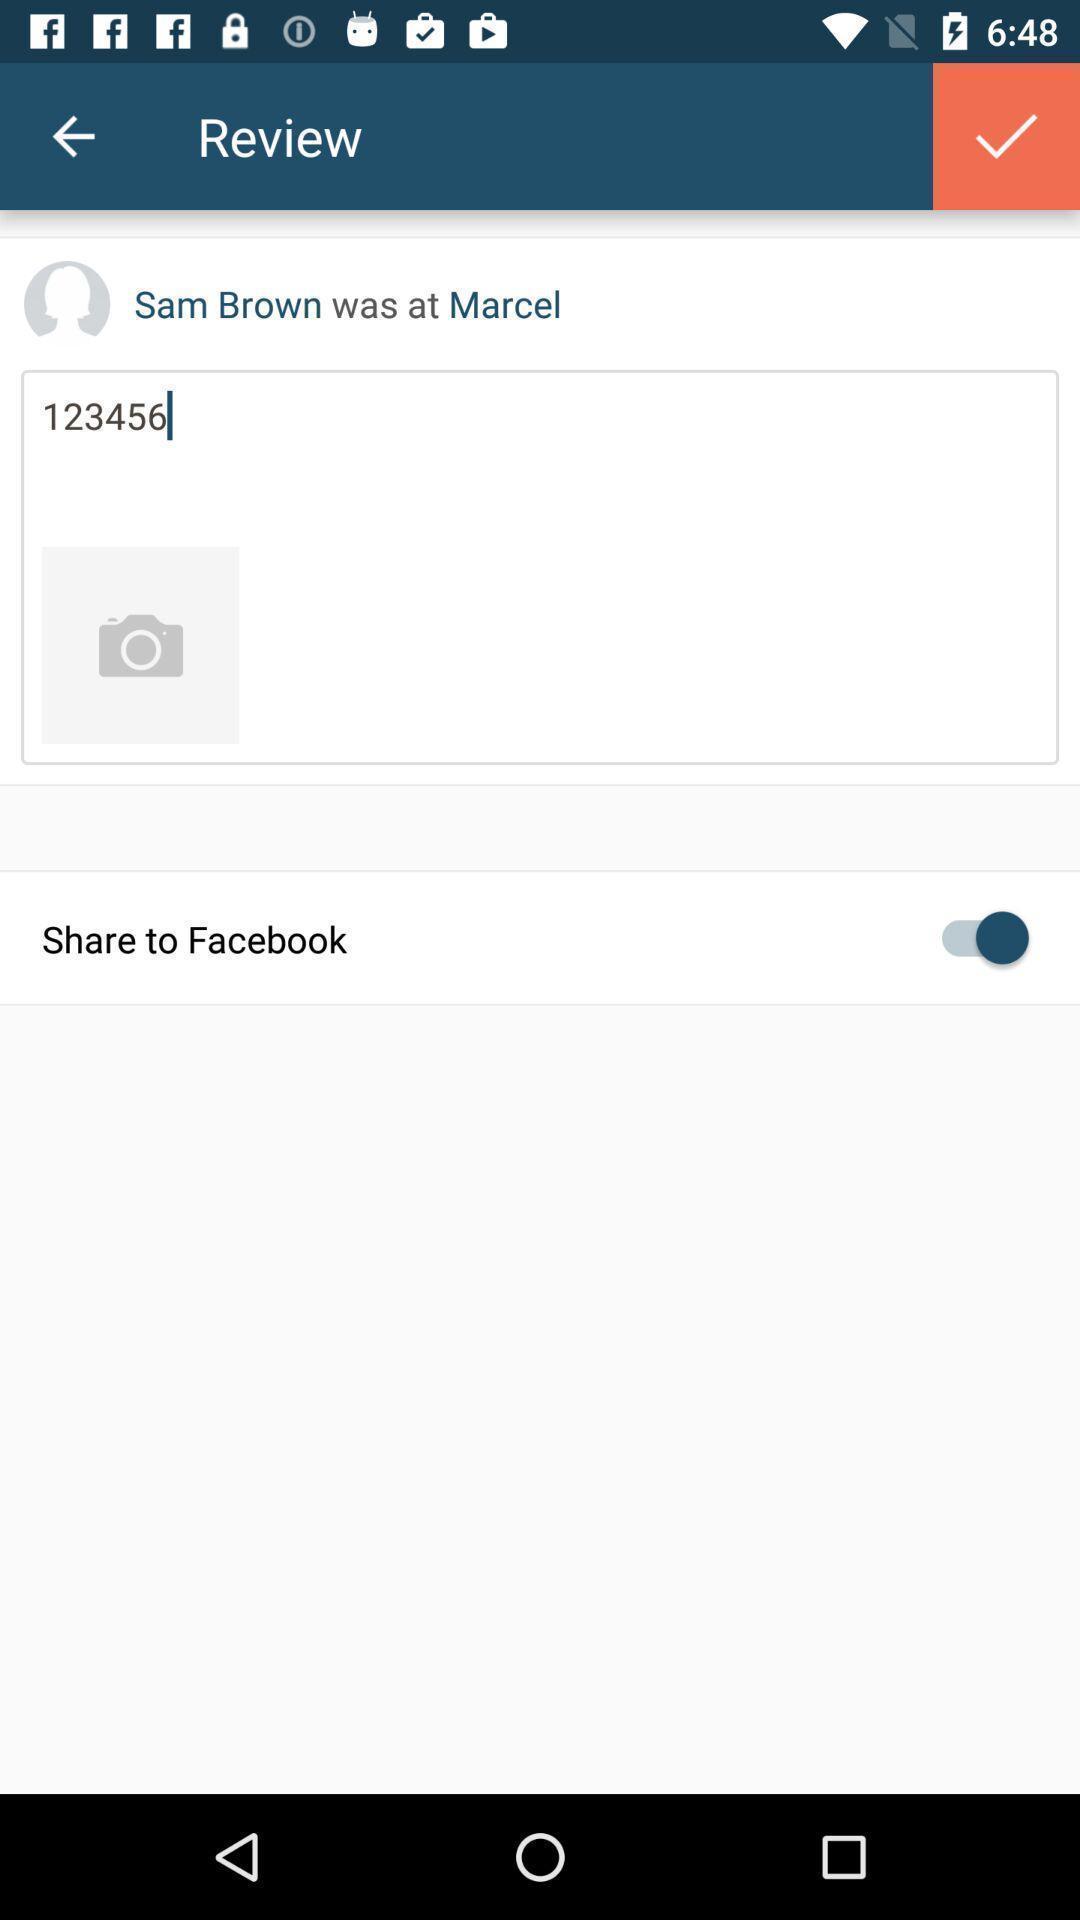Provide a textual representation of this image. Screen showing review page. 